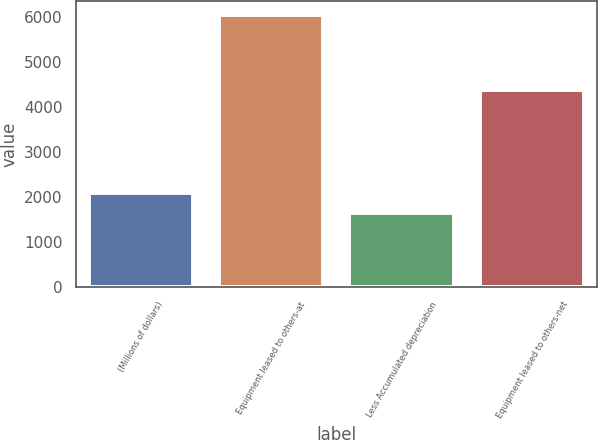<chart> <loc_0><loc_0><loc_500><loc_500><bar_chart><fcel>(Millions of dollars)<fcel>Equipment leased to others-at<fcel>Less Accumulated depreciation<fcel>Equipment leased to others-net<nl><fcel>2094.2<fcel>6038<fcel>1656<fcel>4382<nl></chart> 